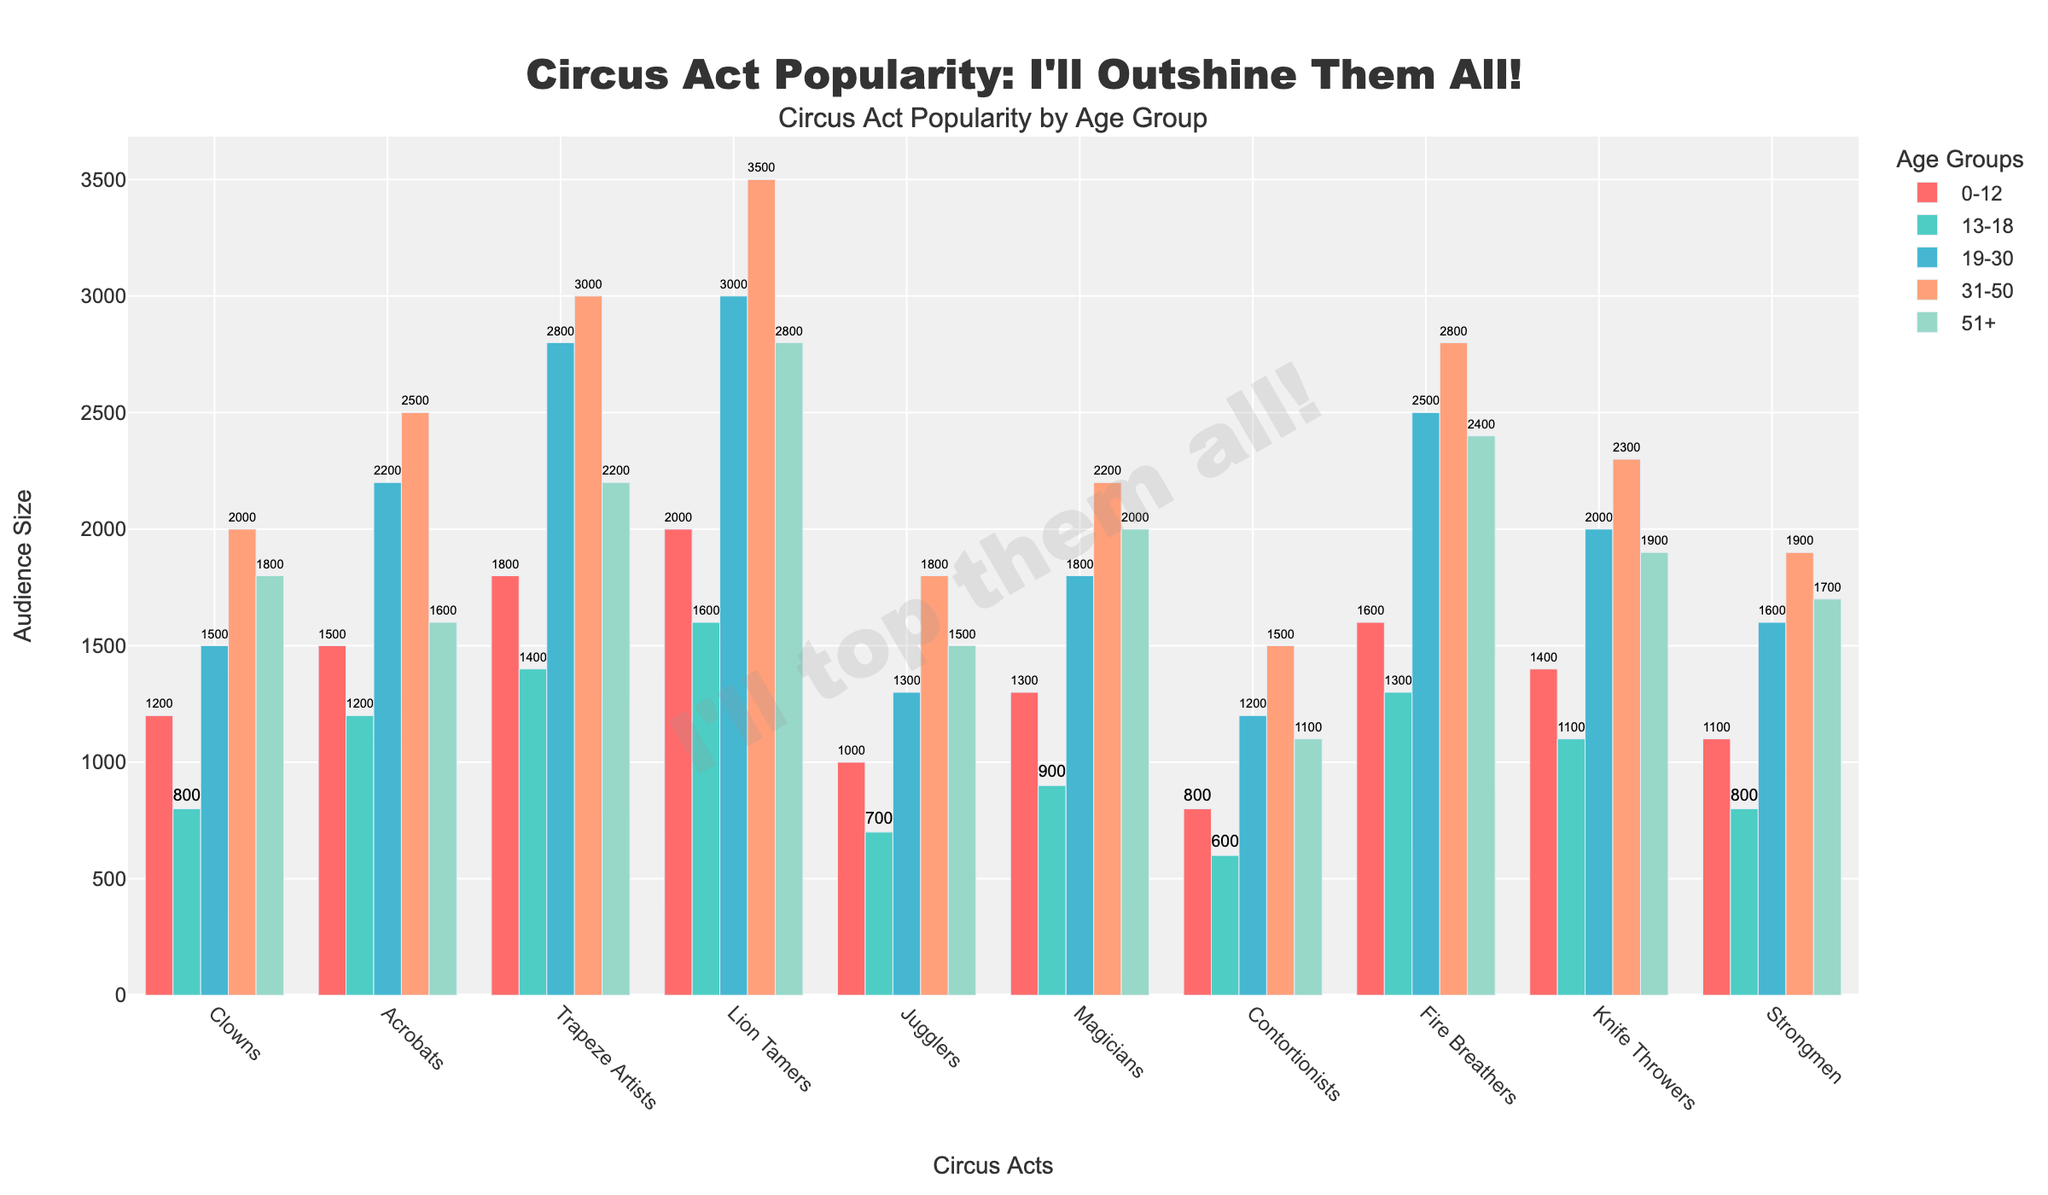what's the age group that attends the acrobats show the most? By looking at the heights of the bars representing each age group for Acrobats, the tallest bar is the one for the age group 31-50, indicating that this group has the highest attendance for the acrobats show.
Answer: 31-50 which act has the highest audience size overall? To determine the act with the highest audience size, identify the act with the tallest bars across all age groups combined. Lion Tamers have consistently high bars across all age groups, indicating it has the largest overall audience.
Answer: Lion Tamers how much larger is the 19-30 age group's attendance for Trapeze Artists compared to Jugglers? First, find the 19-30 age group's attendance for both acts: Trapeze Artists (2800) and Jugglers (1300). Then subtract the smaller value from the larger one: 2800 - 1300 = 1500.
Answer: 1500 for the Fire Breathers, which age group has the lowest attendance? By inspecting the heights of the bars for each age group under the Fire Breathers category, the age group 0-12 has the lowest bar, indicating the lowest attendance.
Answer: 0-12 what's the total audience size for Clowns across all age groups? Sum the audience sizes for Clowns across all age groups: 1200 (0-12) + 800 (13-18) + 1500 (19-30) + 2000 (31-50) + 1800 (51+). The total is 1300.
Answer: 7300 between the Knife Throwers and the Strongmen, which act is more popular among the 51+ age group? Compare the height of the bars for the 51+ age group for both Knife Throwers (1900) and Strongmen (1700). Knife Throwers have a taller bar, indicating higher popularity.
Answer: Knife Throwers which age group has the smallest difference in attendance for Magicians and Contortionists? Calculate the attendance difference for each age group:
0-12: 1300 - 800 = 500,
13-18: 900 - 600 = 300,
19-30: 1800 - 1200 = 600,
31-50: 2200 - 1500 = 700,
51+: 2000 - 1100 = 900,
The smallest difference is 300 for the 13-18 age group.
Answer: 13-18 comparing Clowns and Magicians, which act is more popular in the 13-18 age group? By checking the heights of the bars representing the 13-18 age group, Clowns have an attendance of 800 and Magicians 900. Magicians are more popular.
Answer: Magicians which two acts have the most similar total audience size? Calculate the total audience for each act and compare:
Clowns: 7300,
Acrobats: 9000,
Trapeze Artists: 10200,
Lion Tamers: 12900,
Jugglers: 6300,
Magicians: 8200,
Contortionists: 5200,
Fire Breathers: 10600,
Knife Throwers: 8700,
Strongmen: 7100,
The acts with most similar total audience sizes are Magicians (8200) and Knife Throwers (8700), both differing by only 500.
Answer: Magicians and Knife Throwers 